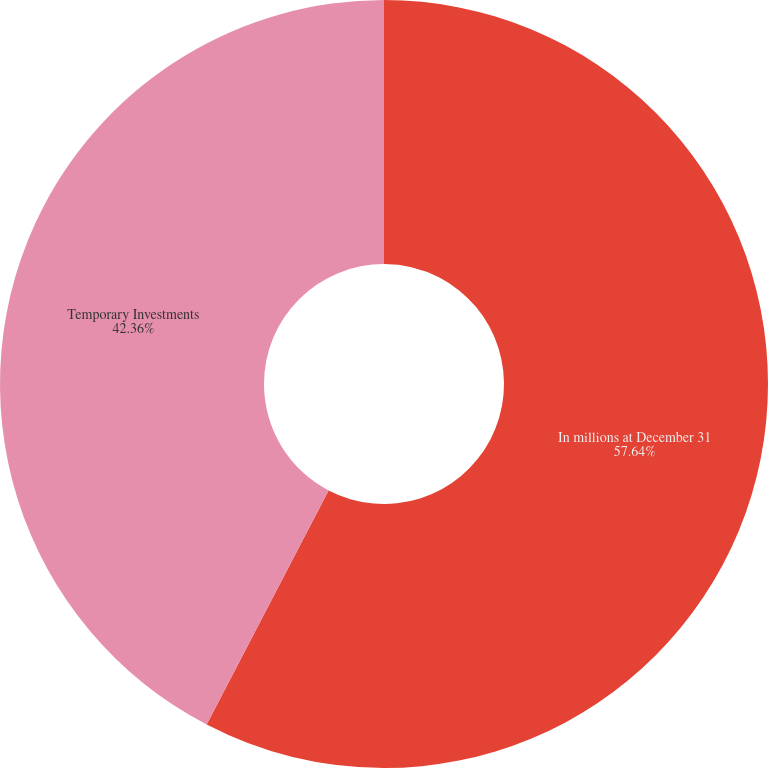<chart> <loc_0><loc_0><loc_500><loc_500><pie_chart><fcel>In millions at December 31<fcel>Temporary Investments<nl><fcel>57.64%<fcel>42.36%<nl></chart> 